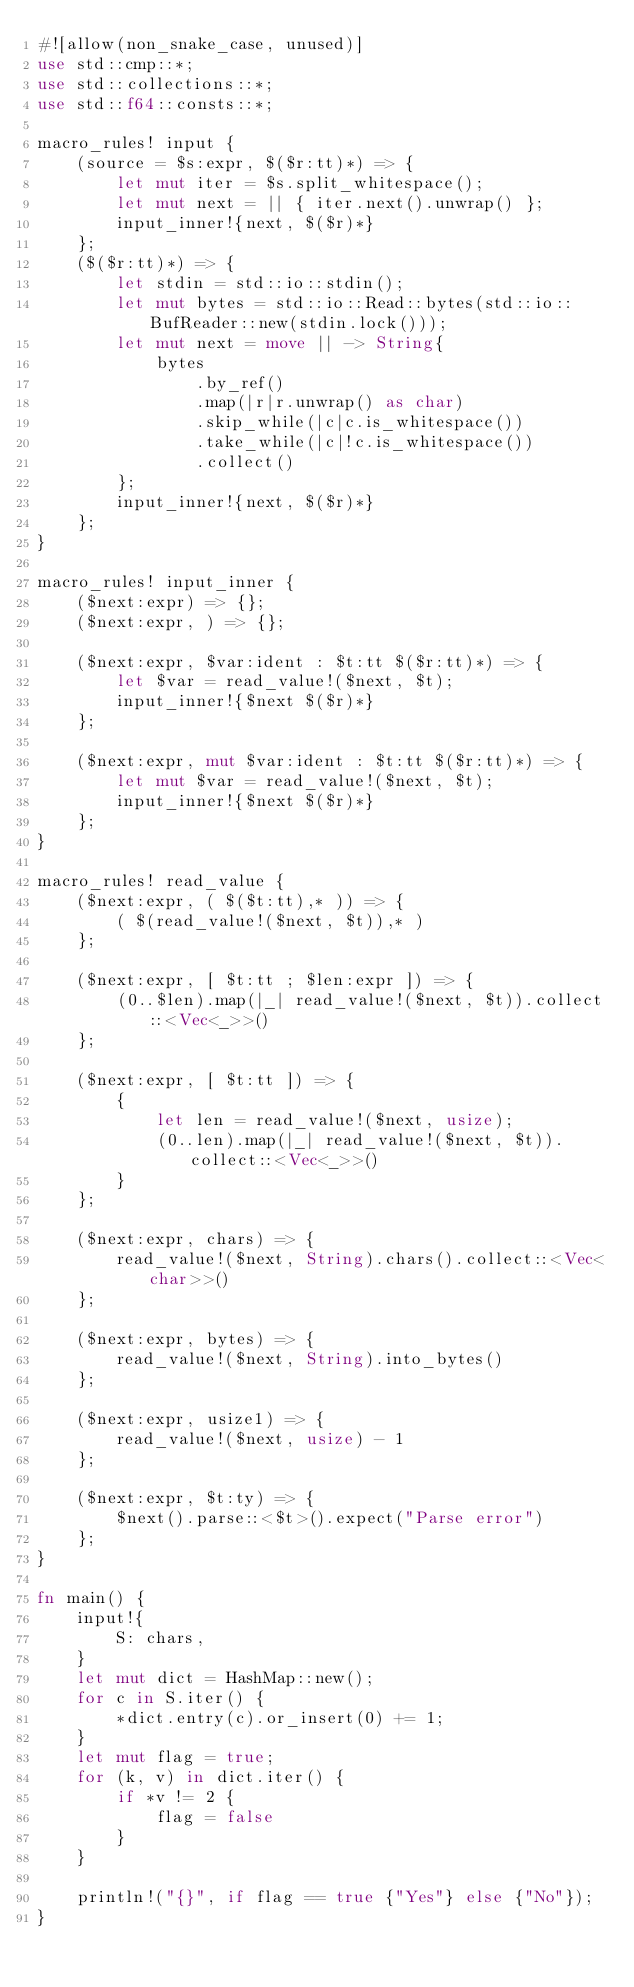<code> <loc_0><loc_0><loc_500><loc_500><_Rust_>#![allow(non_snake_case, unused)]
use std::cmp::*;
use std::collections::*;
use std::f64::consts::*;

macro_rules! input {
    (source = $s:expr, $($r:tt)*) => {
        let mut iter = $s.split_whitespace();
        let mut next = || { iter.next().unwrap() };
        input_inner!{next, $($r)*}
    };
    ($($r:tt)*) => {
        let stdin = std::io::stdin();
        let mut bytes = std::io::Read::bytes(std::io::BufReader::new(stdin.lock()));
        let mut next = move || -> String{
            bytes
                .by_ref()
                .map(|r|r.unwrap() as char)
                .skip_while(|c|c.is_whitespace())
                .take_while(|c|!c.is_whitespace())
                .collect()
        };
        input_inner!{next, $($r)*}
    };
}

macro_rules! input_inner {
    ($next:expr) => {};
    ($next:expr, ) => {};

    ($next:expr, $var:ident : $t:tt $($r:tt)*) => {
        let $var = read_value!($next, $t);
        input_inner!{$next $($r)*}
    };

    ($next:expr, mut $var:ident : $t:tt $($r:tt)*) => {
        let mut $var = read_value!($next, $t);
        input_inner!{$next $($r)*}
    };
}

macro_rules! read_value {
    ($next:expr, ( $($t:tt),* )) => {
        ( $(read_value!($next, $t)),* )
    };

    ($next:expr, [ $t:tt ; $len:expr ]) => {
        (0..$len).map(|_| read_value!($next, $t)).collect::<Vec<_>>()
    };

    ($next:expr, [ $t:tt ]) => {
        {
            let len = read_value!($next, usize);
            (0..len).map(|_| read_value!($next, $t)).collect::<Vec<_>>()
        }
    };

    ($next:expr, chars) => {
        read_value!($next, String).chars().collect::<Vec<char>>()
    };

    ($next:expr, bytes) => {
        read_value!($next, String).into_bytes()
    };

    ($next:expr, usize1) => {
        read_value!($next, usize) - 1
    };

    ($next:expr, $t:ty) => {
        $next().parse::<$t>().expect("Parse error")
    };
}

fn main() {
    input!{
        S: chars,
    }
    let mut dict = HashMap::new();
    for c in S.iter() {
        *dict.entry(c).or_insert(0) += 1;
    }
    let mut flag = true;
    for (k, v) in dict.iter() {
        if *v != 2 {
            flag = false
        }
    }

    println!("{}", if flag == true {"Yes"} else {"No"});
}
</code> 